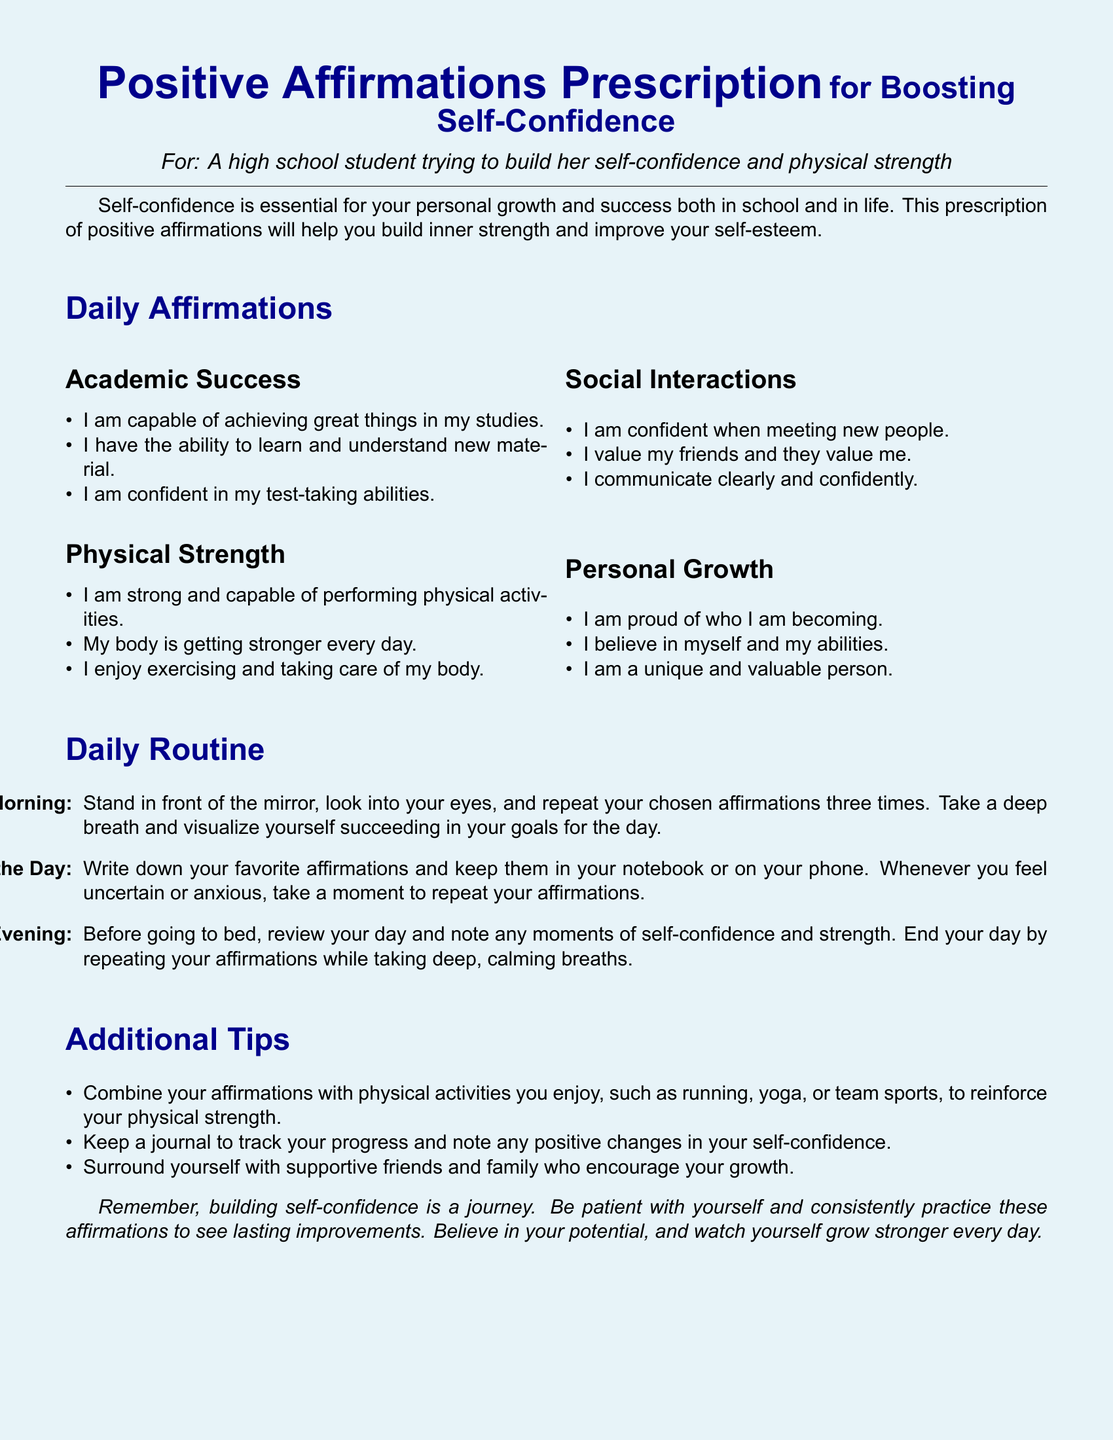What is the title of the document? The title is prominently displayed at the top of the document.
Answer: Positive Affirmations Prescription for Boosting Self-Confidence Who is the prescription intended for? The intended recipient is specified in the document.
Answer: A high school student trying to build her self-confidence and physical strength How many sections are in the Daily Affirmations? The number of sections can be counted in the Daily Affirmations category.
Answer: Four What should you do in the morning according to the Daily Routine? The morning routine is described in the document.
Answer: Repeat your chosen affirmations three times What is one recommended physical activity mentioned in the Additional Tips? Physical activities are listed in the document under Additional Tips.
Answer: Running What should you keep to track your progress? The document suggests a method for tracking self-confidence growth.
Answer: A journal How many affirmations are listed under Social Interactions? The number of affirmations can be counted in the specific category.
Answer: Three What phrase is included in the Personal Growth affirmations? Affirmations in this section contain specific phrases.
Answer: I am a unique and valuable person 